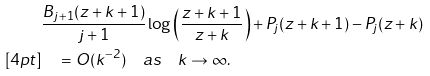Convert formula to latex. <formula><loc_0><loc_0><loc_500><loc_500>& \frac { B _ { j + 1 } ( z + k + 1 ) } { j + 1 } \log \left ( \frac { z + k + 1 } { z + k } \right ) + P _ { j } ( z + k + 1 ) - P _ { j } ( z + k ) \\ [ 4 p t ] & \quad = O ( k ^ { - 2 } ) \quad a s \quad k \to \infty .</formula> 